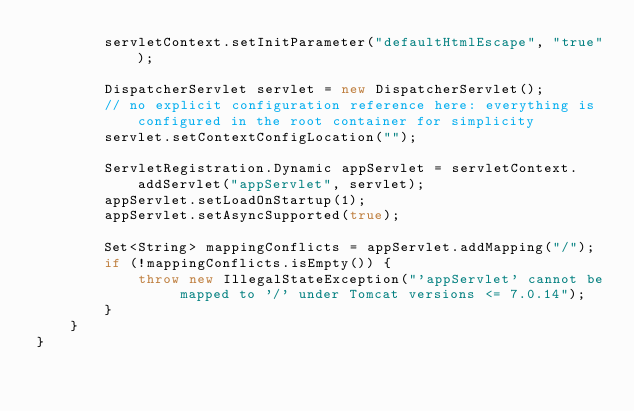Convert code to text. <code><loc_0><loc_0><loc_500><loc_500><_Java_>		servletContext.setInitParameter("defaultHtmlEscape", "true");
		
		DispatcherServlet servlet = new DispatcherServlet();
		// no explicit configuration reference here: everything is configured in the root container for simplicity
		servlet.setContextConfigLocation("");
		
		ServletRegistration.Dynamic appServlet = servletContext.addServlet("appServlet", servlet);
		appServlet.setLoadOnStartup(1);
		appServlet.setAsyncSupported(true);
		
		Set<String> mappingConflicts = appServlet.addMapping("/");
		if (!mappingConflicts.isEmpty()) {
			throw new IllegalStateException("'appServlet' cannot be mapped to '/' under Tomcat versions <= 7.0.14");
		}
	}
}</code> 